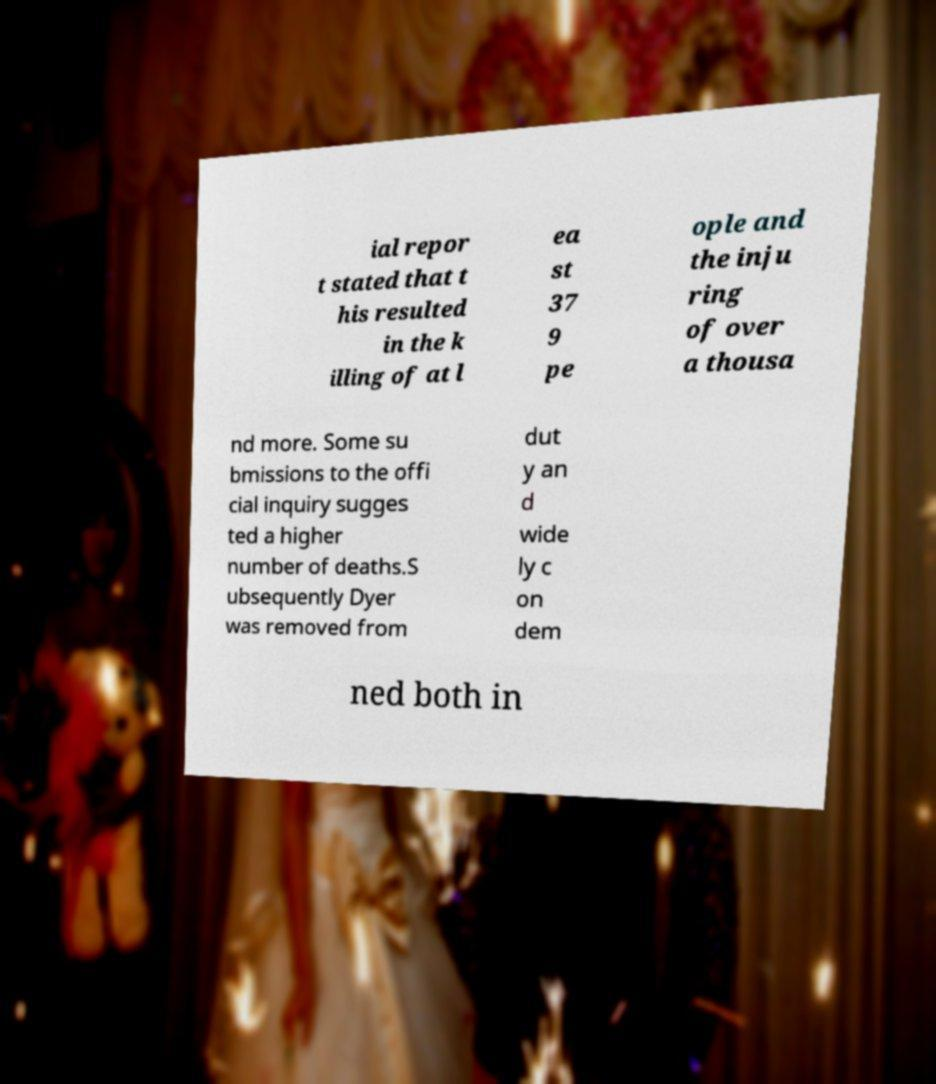I need the written content from this picture converted into text. Can you do that? ial repor t stated that t his resulted in the k illing of at l ea st 37 9 pe ople and the inju ring of over a thousa nd more. Some su bmissions to the offi cial inquiry sugges ted a higher number of deaths.S ubsequently Dyer was removed from dut y an d wide ly c on dem ned both in 